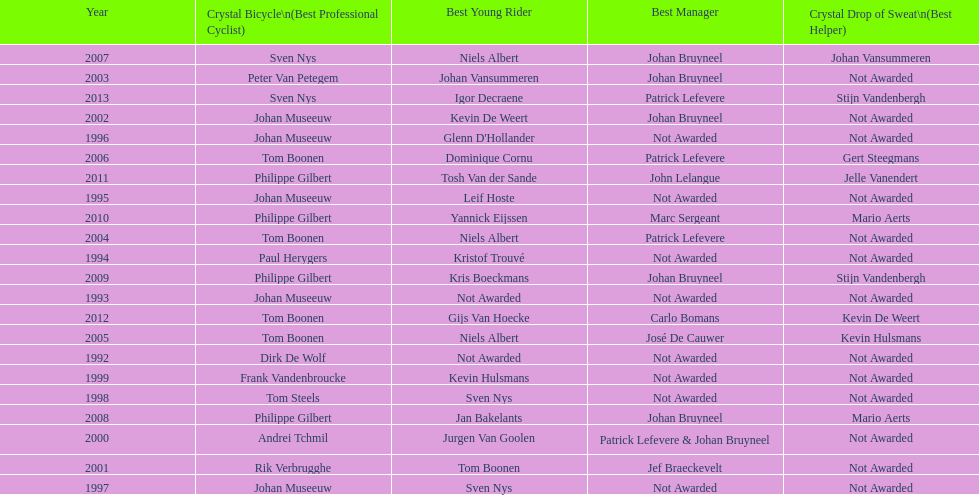What is the total number of times johan bryneel's name appears on all of these lists? 6. 